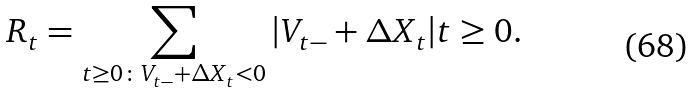<formula> <loc_0><loc_0><loc_500><loc_500>R _ { t } = \sum _ { t \geq 0 \colon V _ { t - } + \Delta X _ { t } < 0 } | V _ { t - } + \Delta X _ { t } | t \geq 0 .</formula> 